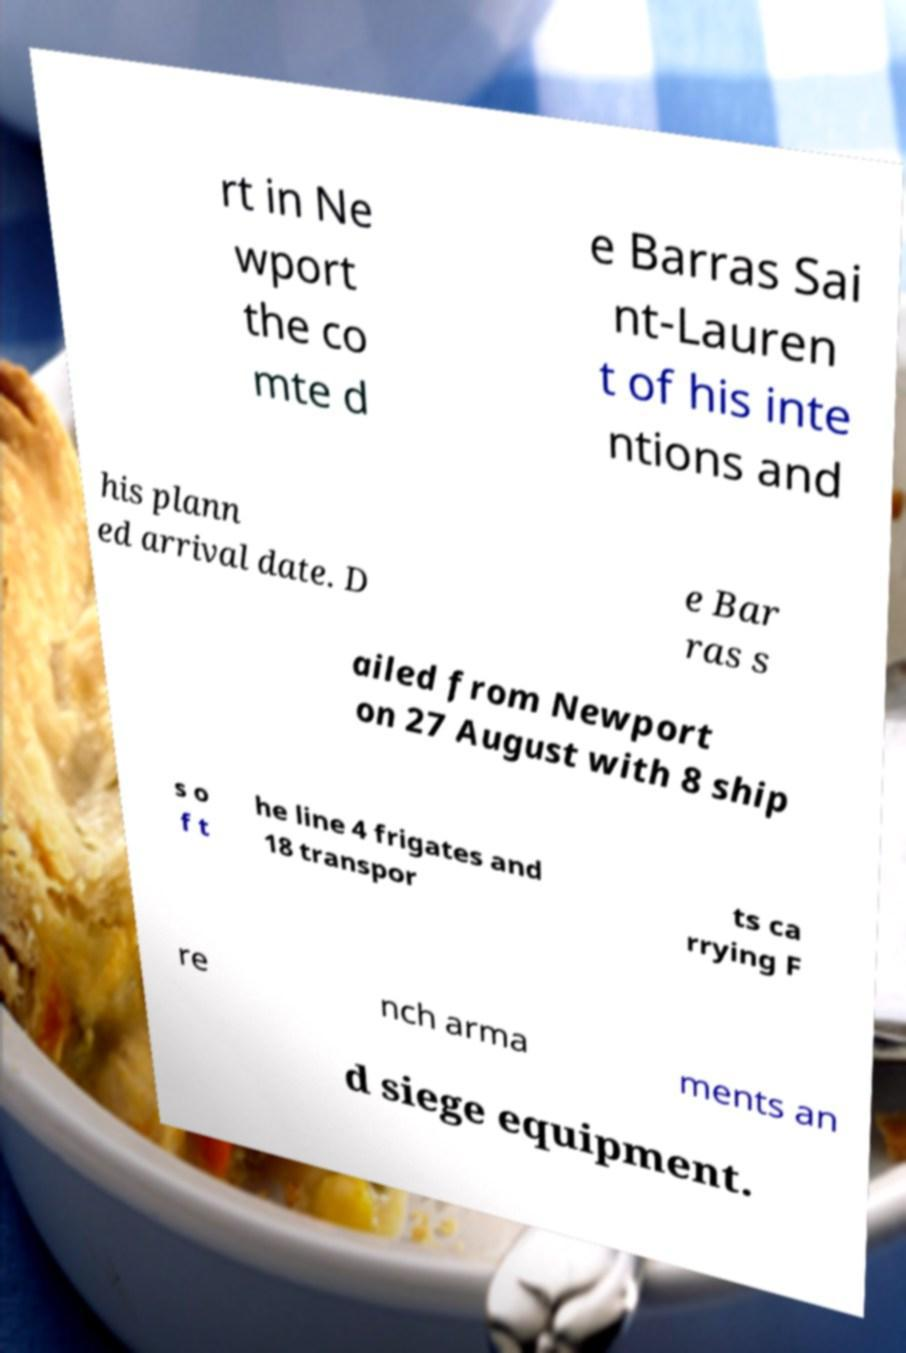Could you assist in decoding the text presented in this image and type it out clearly? rt in Ne wport the co mte d e Barras Sai nt-Lauren t of his inte ntions and his plann ed arrival date. D e Bar ras s ailed from Newport on 27 August with 8 ship s o f t he line 4 frigates and 18 transpor ts ca rrying F re nch arma ments an d siege equipment. 